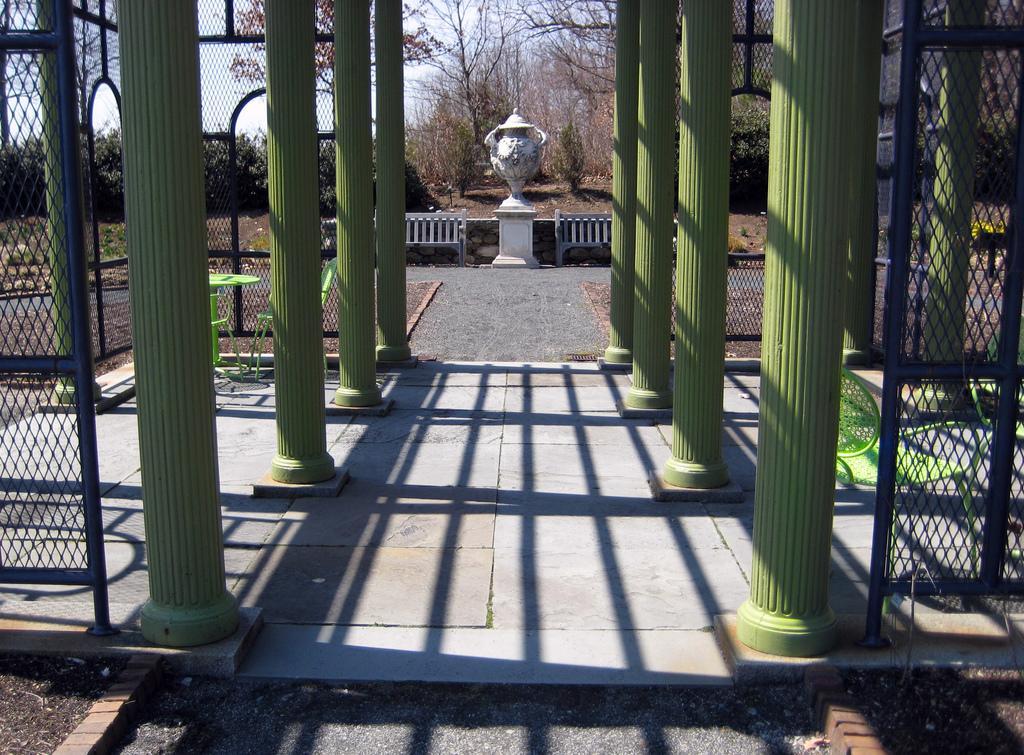Please provide a concise description of this image. In this image I can see a fence, pillars, memorial, trees and the sky. This image is taken may be during a day. 